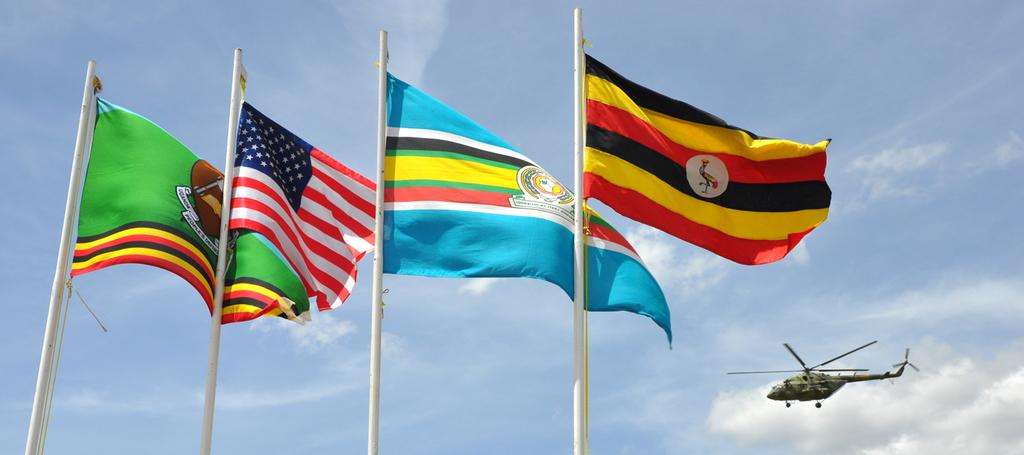What can be seen in the foreground of the image? There are poles and flags in the foreground of the image. What is located on the right side of the image? There is a helicopter on the right side of the image. What is visible in the background of the image? The sky is visible in the background of the image. Where is the rod holding the apple on the table in the image? There is no rod holding an apple on a table present in the image. What type of table is visible in the image? There is no table present in the image. 